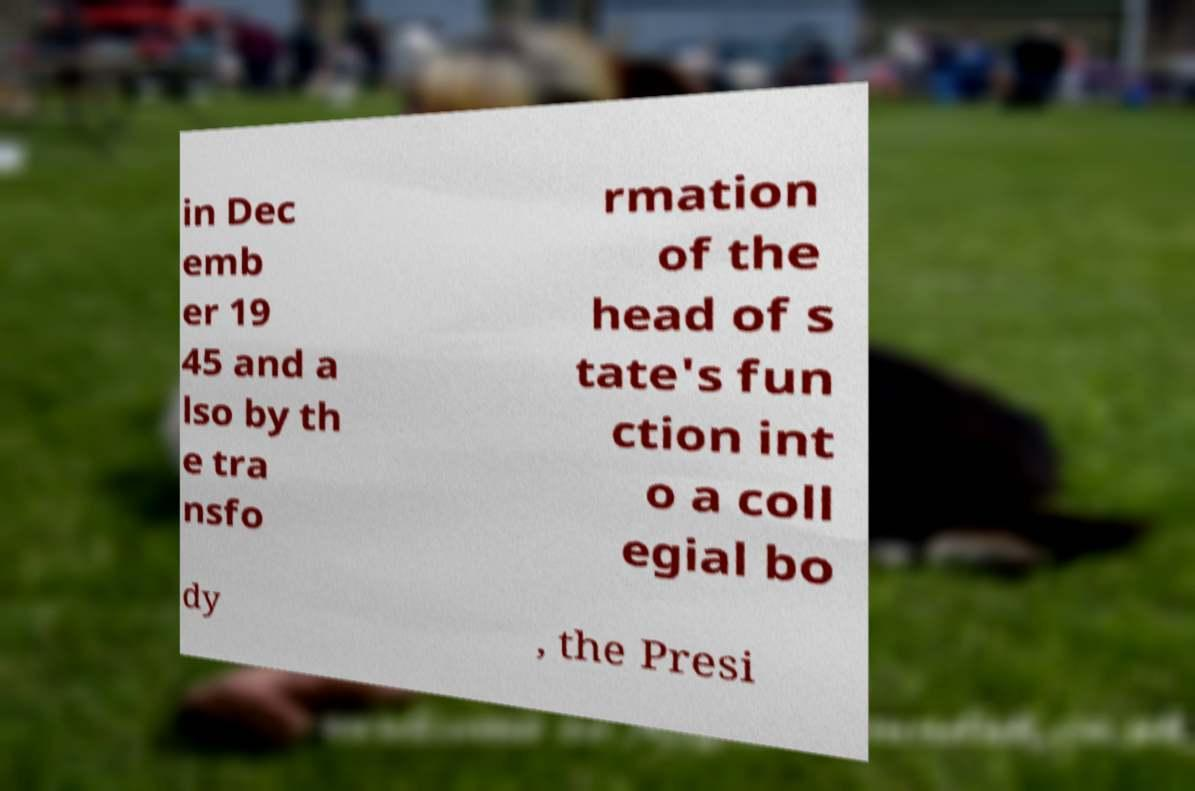For documentation purposes, I need the text within this image transcribed. Could you provide that? in Dec emb er 19 45 and a lso by th e tra nsfo rmation of the head of s tate's fun ction int o a coll egial bo dy , the Presi 